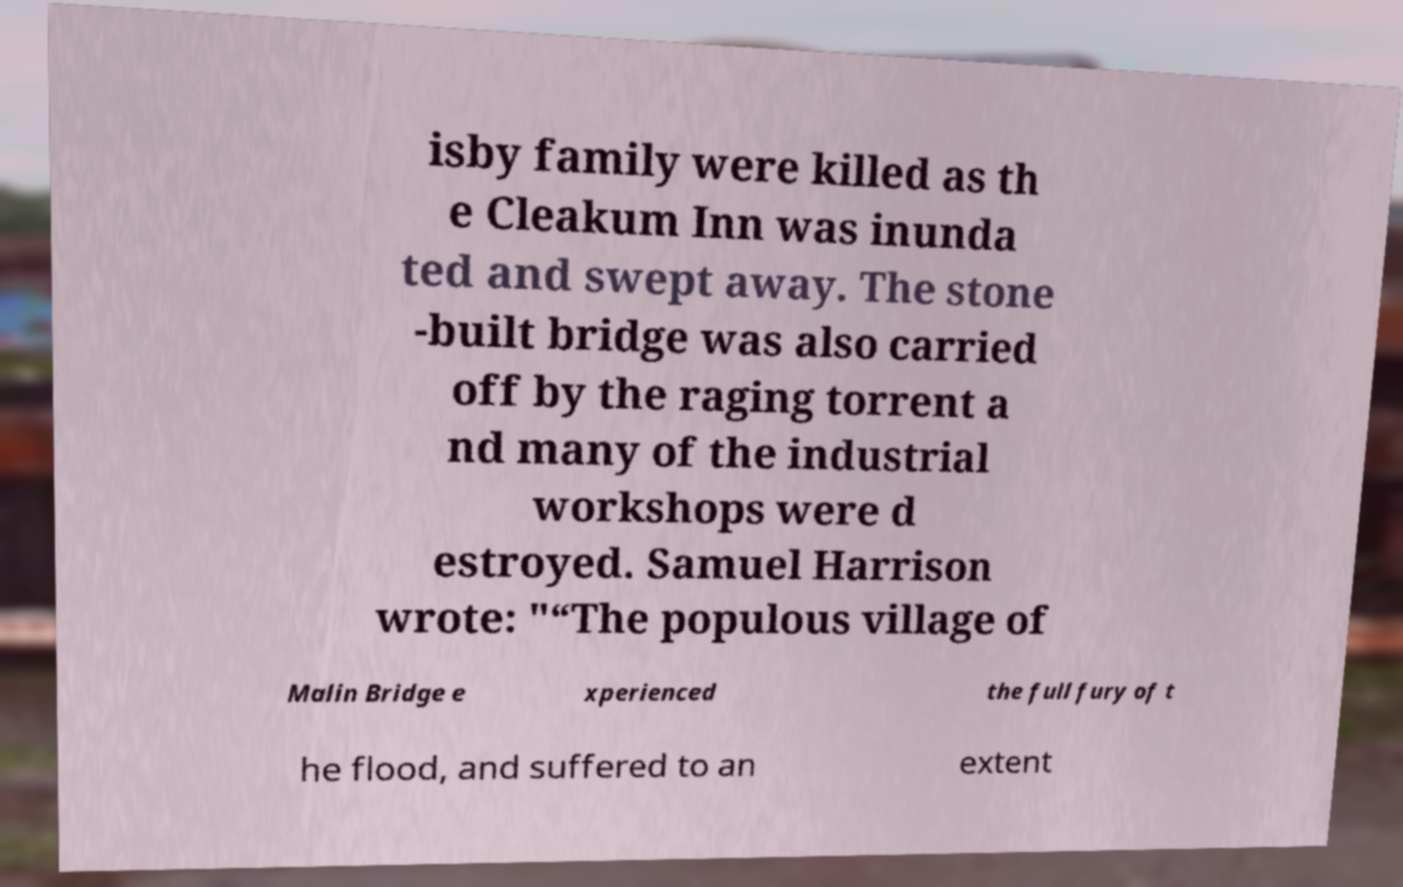There's text embedded in this image that I need extracted. Can you transcribe it verbatim? isby family were killed as th e Cleakum Inn was inunda ted and swept away. The stone -built bridge was also carried off by the raging torrent a nd many of the industrial workshops were d estroyed. Samuel Harrison wrote: "“The populous village of Malin Bridge e xperienced the full fury of t he flood, and suffered to an extent 